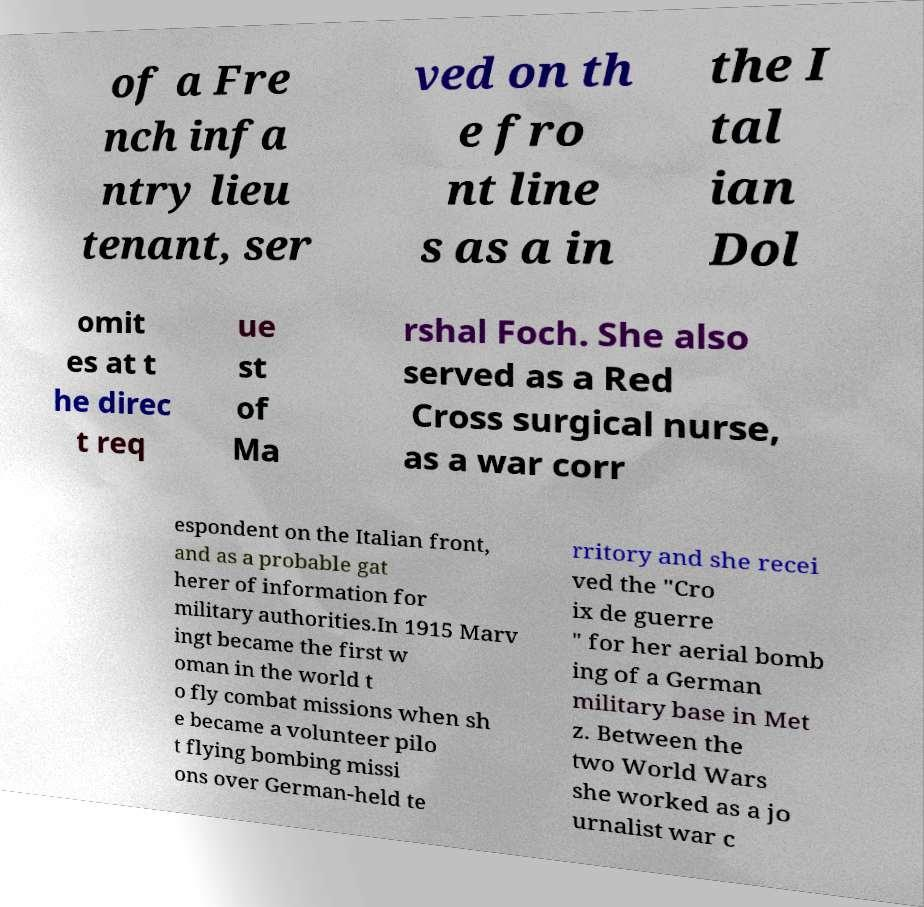For documentation purposes, I need the text within this image transcribed. Could you provide that? of a Fre nch infa ntry lieu tenant, ser ved on th e fro nt line s as a in the I tal ian Dol omit es at t he direc t req ue st of Ma rshal Foch. She also served as a Red Cross surgical nurse, as a war corr espondent on the Italian front, and as a probable gat herer of information for military authorities.In 1915 Marv ingt became the first w oman in the world t o fly combat missions when sh e became a volunteer pilo t flying bombing missi ons over German-held te rritory and she recei ved the "Cro ix de guerre " for her aerial bomb ing of a German military base in Met z. Between the two World Wars she worked as a jo urnalist war c 